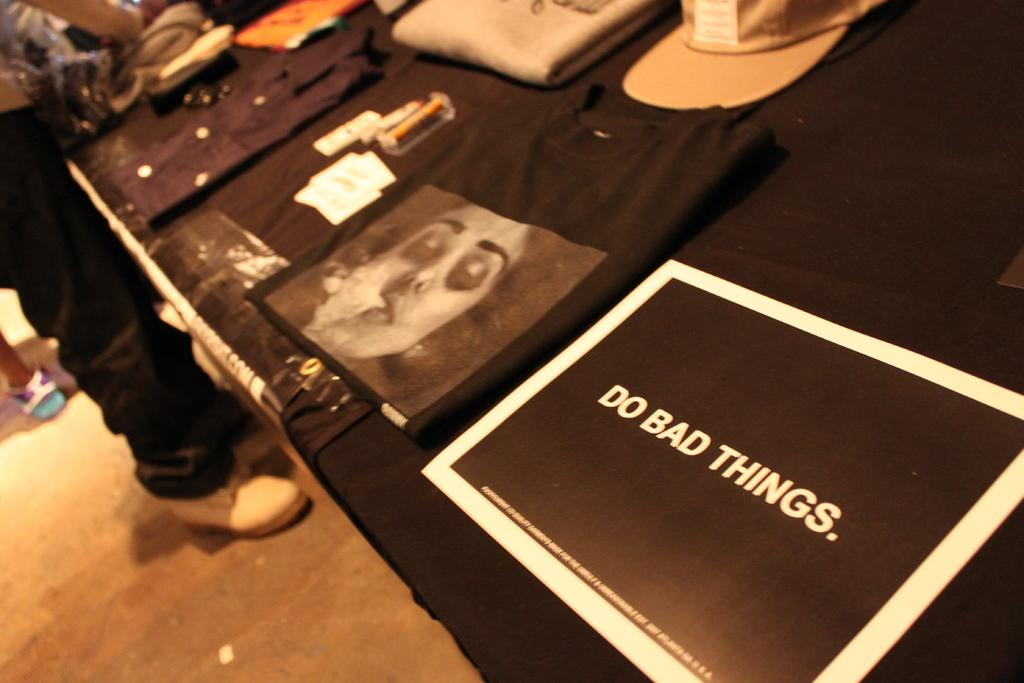What is the main object in the image? There is a table in the image. What is on top of the table? There are clothes on the table. Is there anyone near the table? Yes, there is a person standing in front of the table. What type of current can be seen flowing under the table in the image? There is no current visible in the image, as it is not mentioned in the facts provided. 